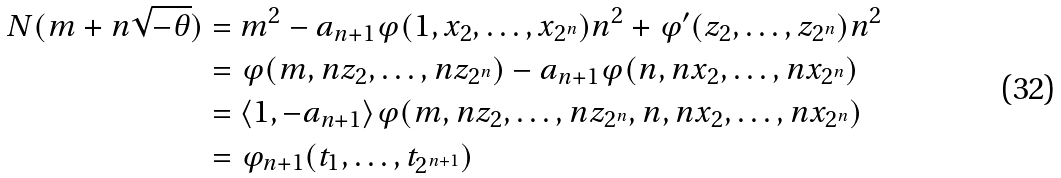<formula> <loc_0><loc_0><loc_500><loc_500>N ( m + n \sqrt { - \theta } ) & = m ^ { 2 } - a _ { n + 1 } \varphi ( 1 , x _ { 2 } , \dots , x _ { 2 ^ { n } } ) n ^ { 2 } + \varphi ^ { \prime } ( z _ { 2 } , \dots , z _ { 2 ^ { n } } ) n ^ { 2 } \\ & = \varphi ( m , n z _ { 2 } , \dots , n z _ { 2 ^ { n } } ) - a _ { n + 1 } \varphi ( n , n x _ { 2 } , \dots , n x _ { 2 ^ { n } } ) \\ & = \langle 1 , - a _ { n + 1 } \rangle \varphi ( m , n z _ { 2 } , \dots , n z _ { 2 ^ { n } } , n , n x _ { 2 } , \dots , n x _ { 2 ^ { n } } ) \\ & = \varphi _ { n + 1 } ( t _ { 1 } , \dots , t _ { 2 ^ { n + 1 } } )</formula> 